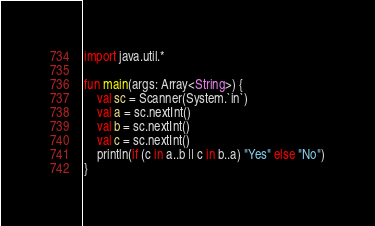Convert code to text. <code><loc_0><loc_0><loc_500><loc_500><_Kotlin_>import java.util.*

fun main(args: Array<String>) {
    val sc = Scanner(System.`in`)
    val a = sc.nextInt()
    val b = sc.nextInt()
    val c = sc.nextInt()
    println(if (c in a..b || c in b..a) "Yes" else "No")
}</code> 